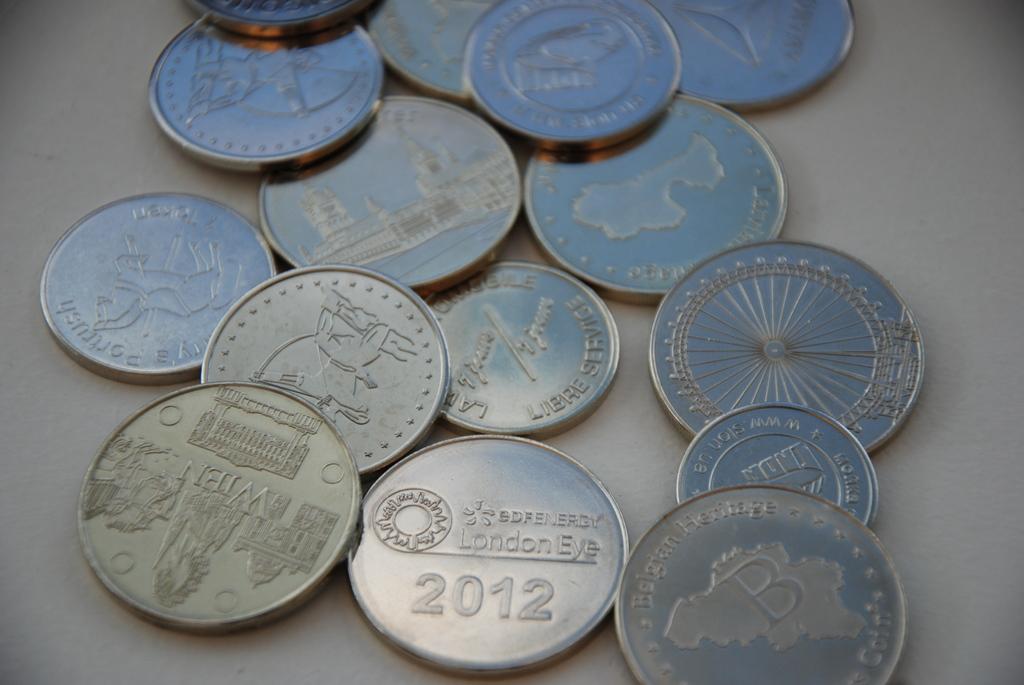What year is commemorated on the london eye coin?
Your answer should be very brief. 2012. 